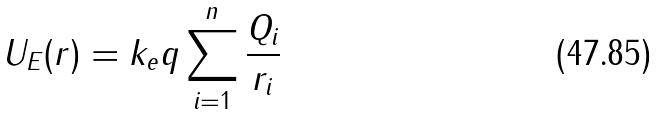<formula> <loc_0><loc_0><loc_500><loc_500>U _ { E } ( r ) = k _ { e } q \sum _ { i = 1 } ^ { n } \frac { Q _ { i } } { r _ { i } }</formula> 